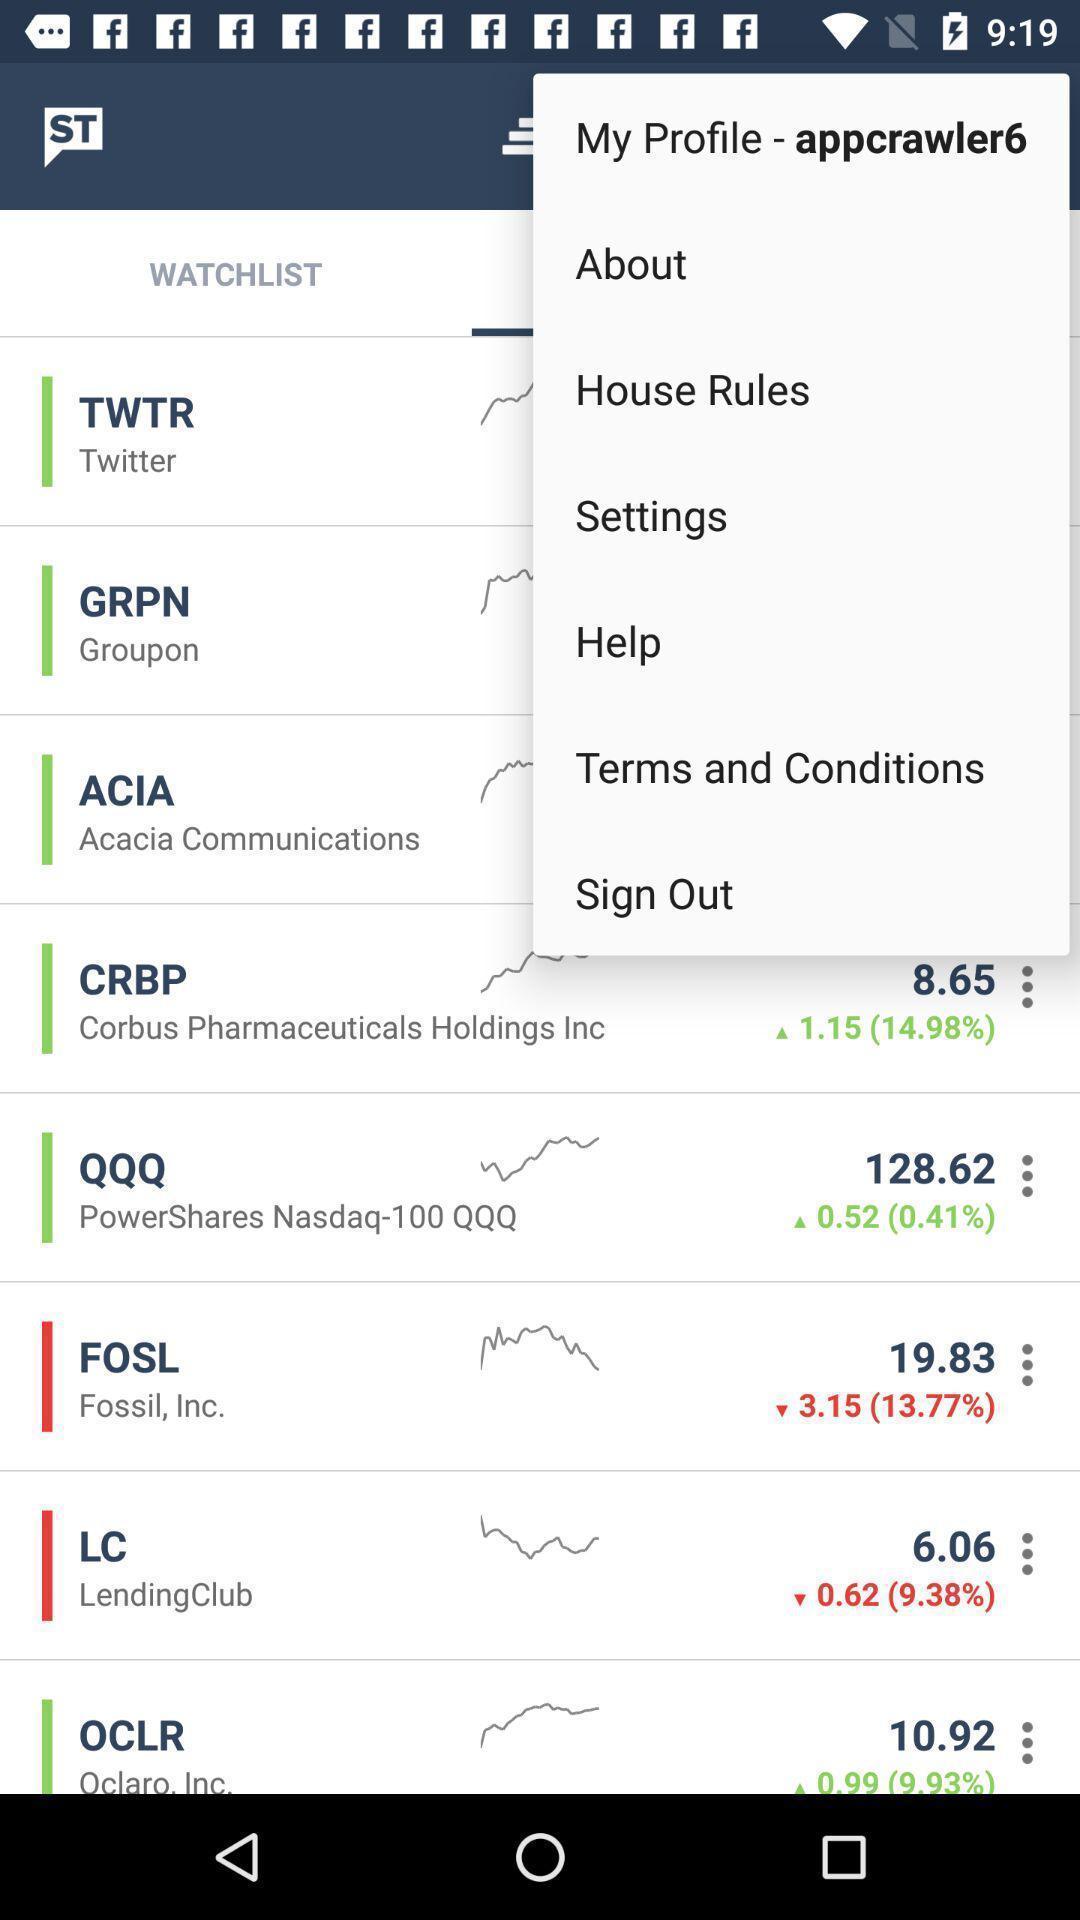Give me a summary of this screen capture. Popup displaying list of information about a trading application. 